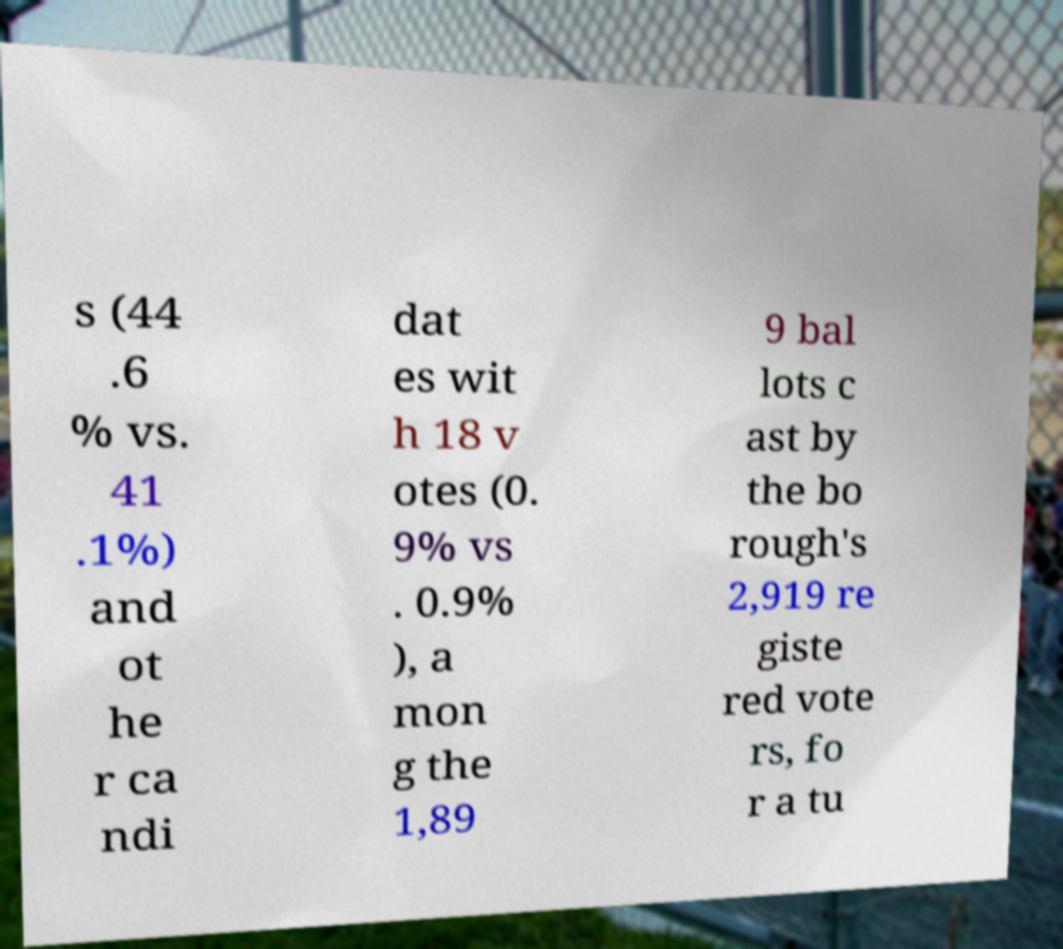Can you read and provide the text displayed in the image?This photo seems to have some interesting text. Can you extract and type it out for me? s (44 .6 % vs. 41 .1%) and ot he r ca ndi dat es wit h 18 v otes (0. 9% vs . 0.9% ), a mon g the 1,89 9 bal lots c ast by the bo rough's 2,919 re giste red vote rs, fo r a tu 